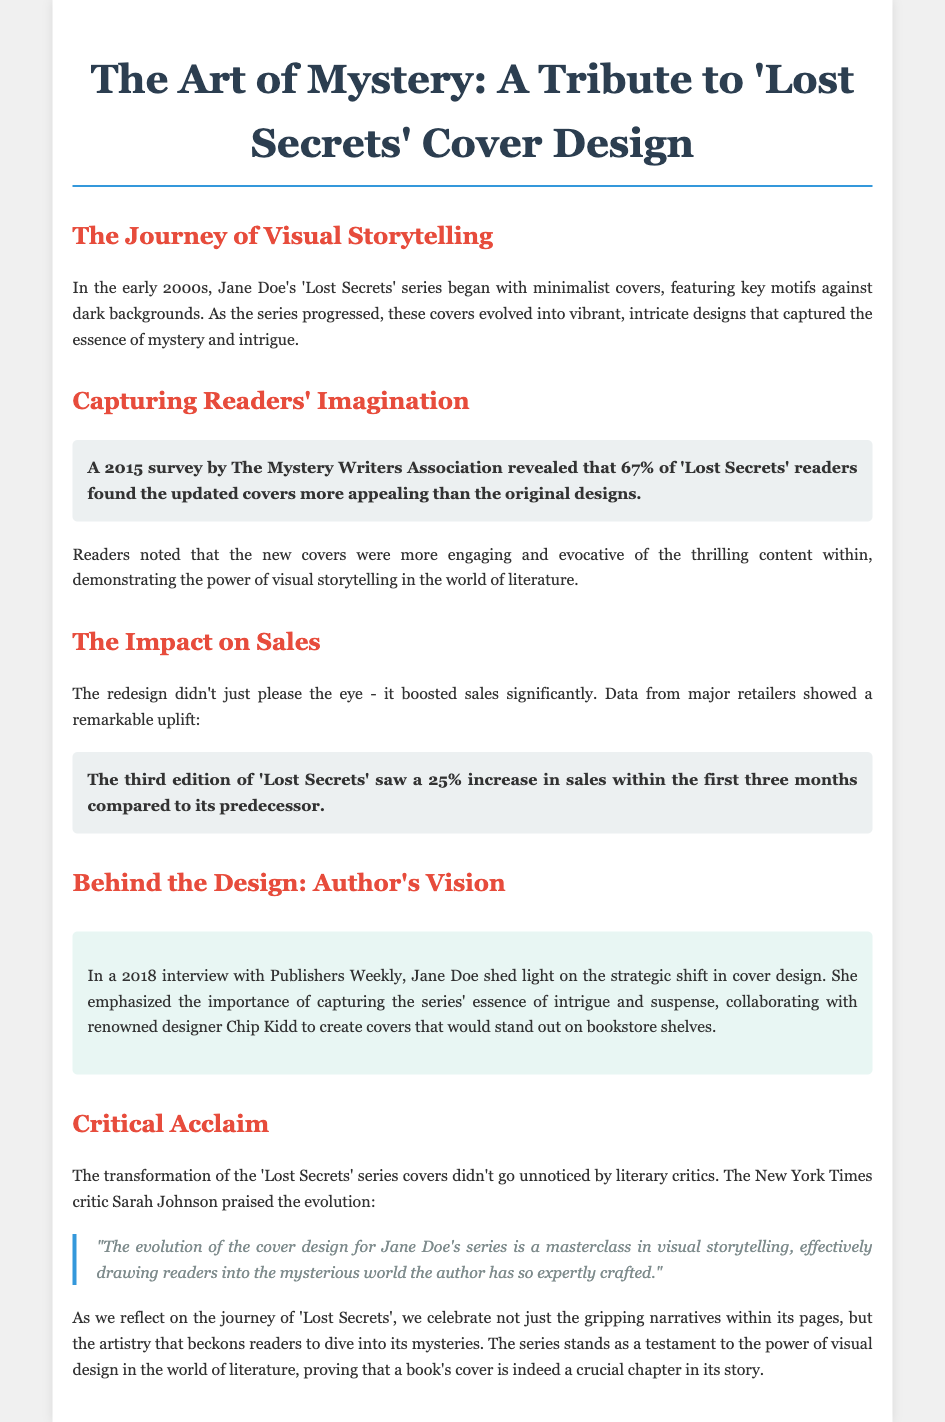what is the name of the series discussed in the eulogy? The eulogy discusses the 'Lost Secrets' series, which is the central focus of the document.
Answer: 'Lost Secrets' who is the author of the series? The author of the series is mentioned as Jane Doe in the document.
Answer: Jane Doe what percentage of readers found the updated covers more appealing? The document states that a 2015 survey revealed 67% of readers found the updated covers more appealing.
Answer: 67% what was the sales increase percentage for the third edition within the first three months? According to the document, the third edition saw a 25% increase in sales within the first three months compared to its predecessor.
Answer: 25% who collaborated with Jane Doe for the design? The document mentions that Jane Doe collaborated with renowned designer Chip Kidd.
Answer: Chip Kidd what does Sarah Johnson praise the evolution of in her quote? Sarah Johnson praises the evolution of the cover design as a masterclass in visual storytelling.
Answer: cover design what year did Jane Doe give an interview about the strategic shift? The document notes that Jane Doe gave the interview in 2018.
Answer: 2018 how did the redesign impact sales? The eulogy highlights that the redesign boosted sales significantly, indicating that cover design can influence reader engagement and market performance.
Answer: boosted sales significantly what role does the document attribute to visual design in literature? The document emphasizes that visual design plays a crucial role in attracting readers to literature.
Answer: crucial role 